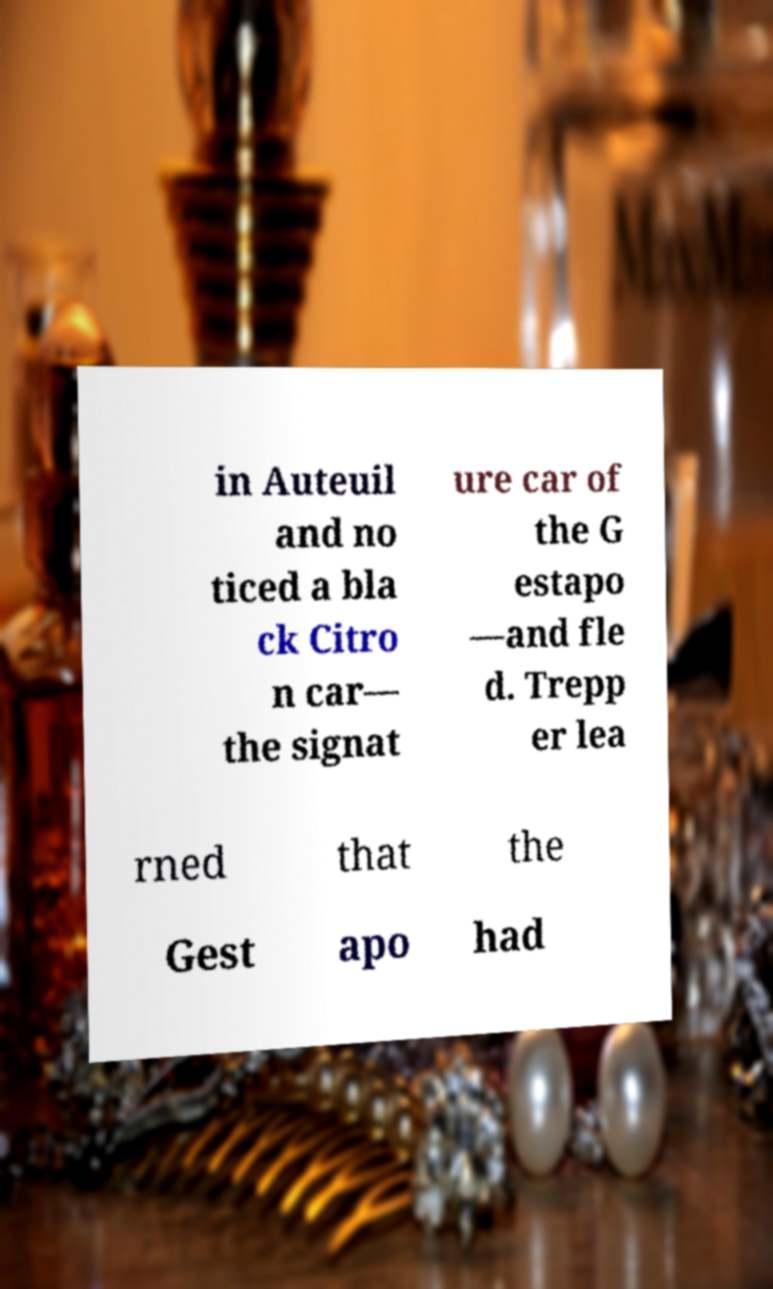Could you assist in decoding the text presented in this image and type it out clearly? in Auteuil and no ticed a bla ck Citro n car— the signat ure car of the G estapo —and fle d. Trepp er lea rned that the Gest apo had 